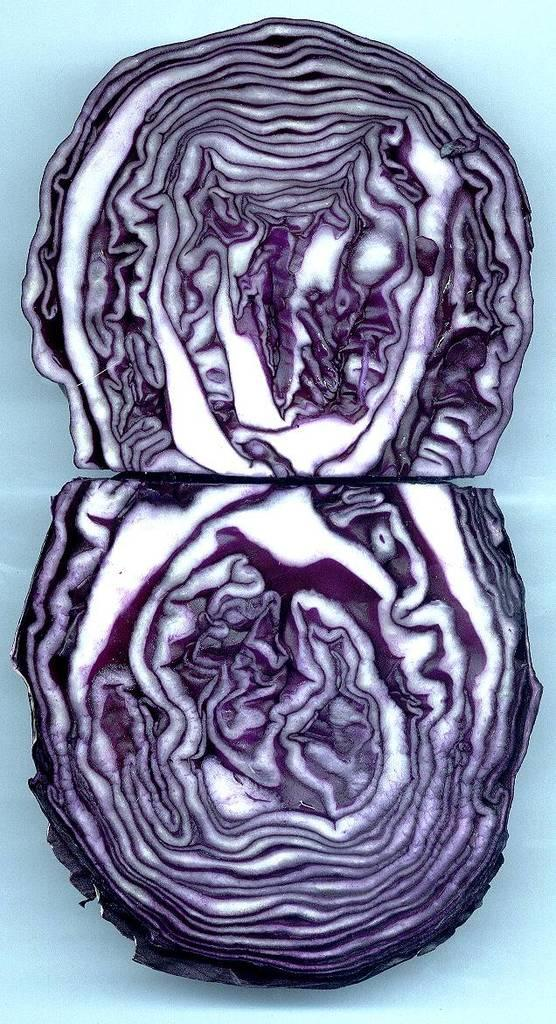What type of vegetable is in the image? There is a red cabbage in the image. Where is the red cabbage located? The red cabbage is on a surface. What type of tools does the carpenter use in the image? There is no carpenter present in the image, so it is not possible to answer that question. 